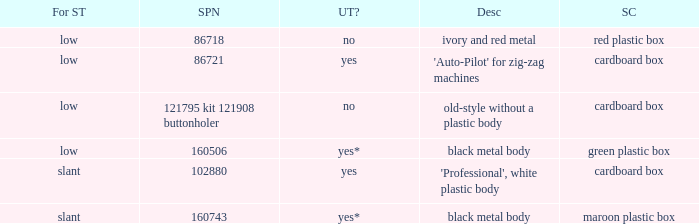What's the shank type of the buttonholer with red plastic box as storage case? Low. 